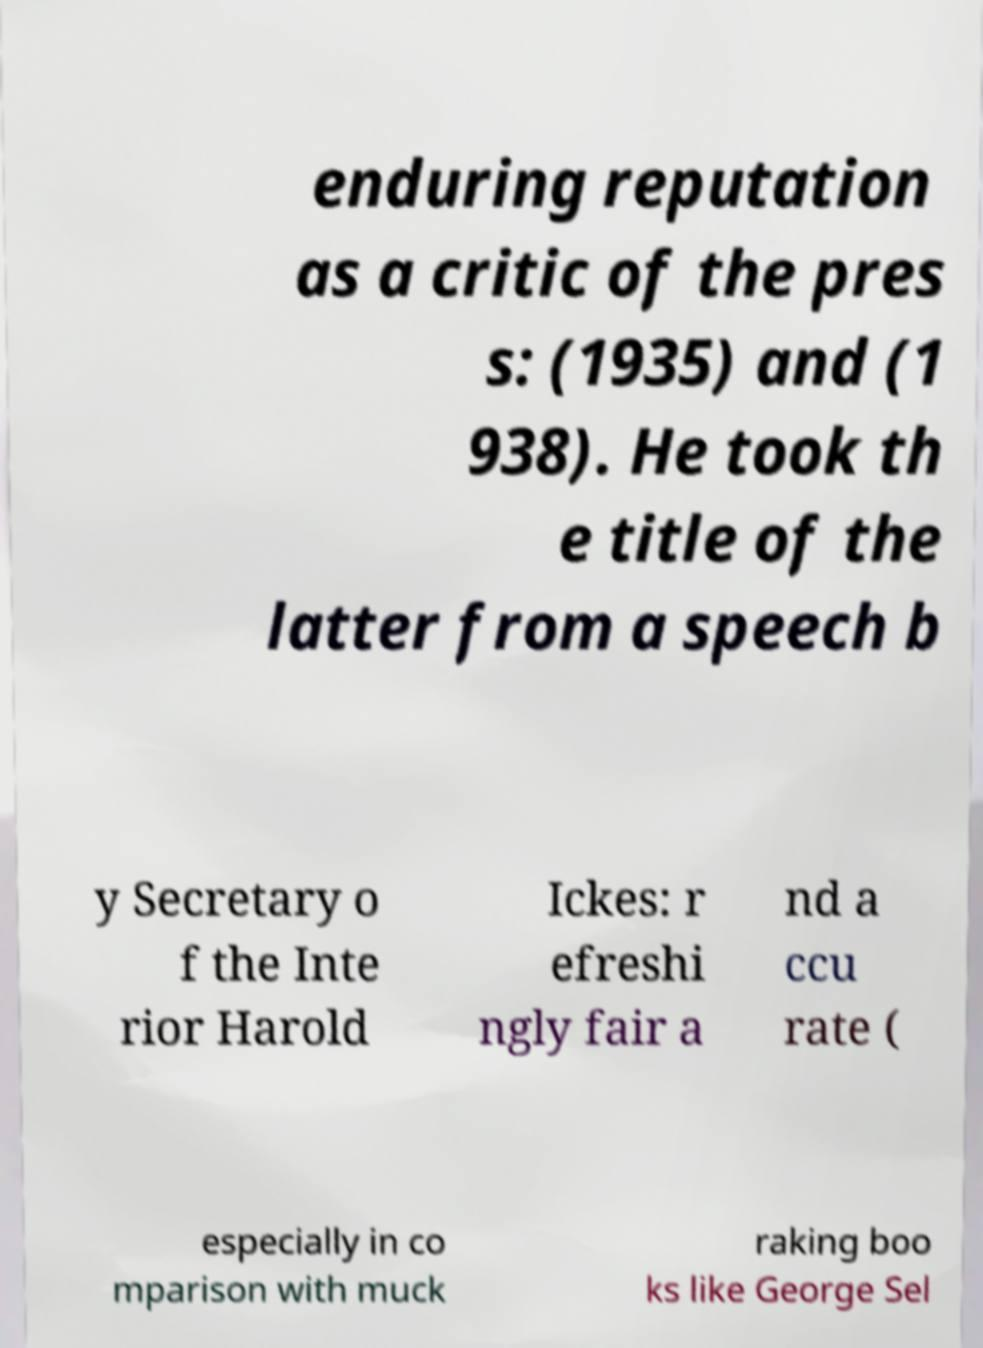Please identify and transcribe the text found in this image. enduring reputation as a critic of the pres s: (1935) and (1 938). He took th e title of the latter from a speech b y Secretary o f the Inte rior Harold Ickes: r efreshi ngly fair a nd a ccu rate ( especially in co mparison with muck raking boo ks like George Sel 